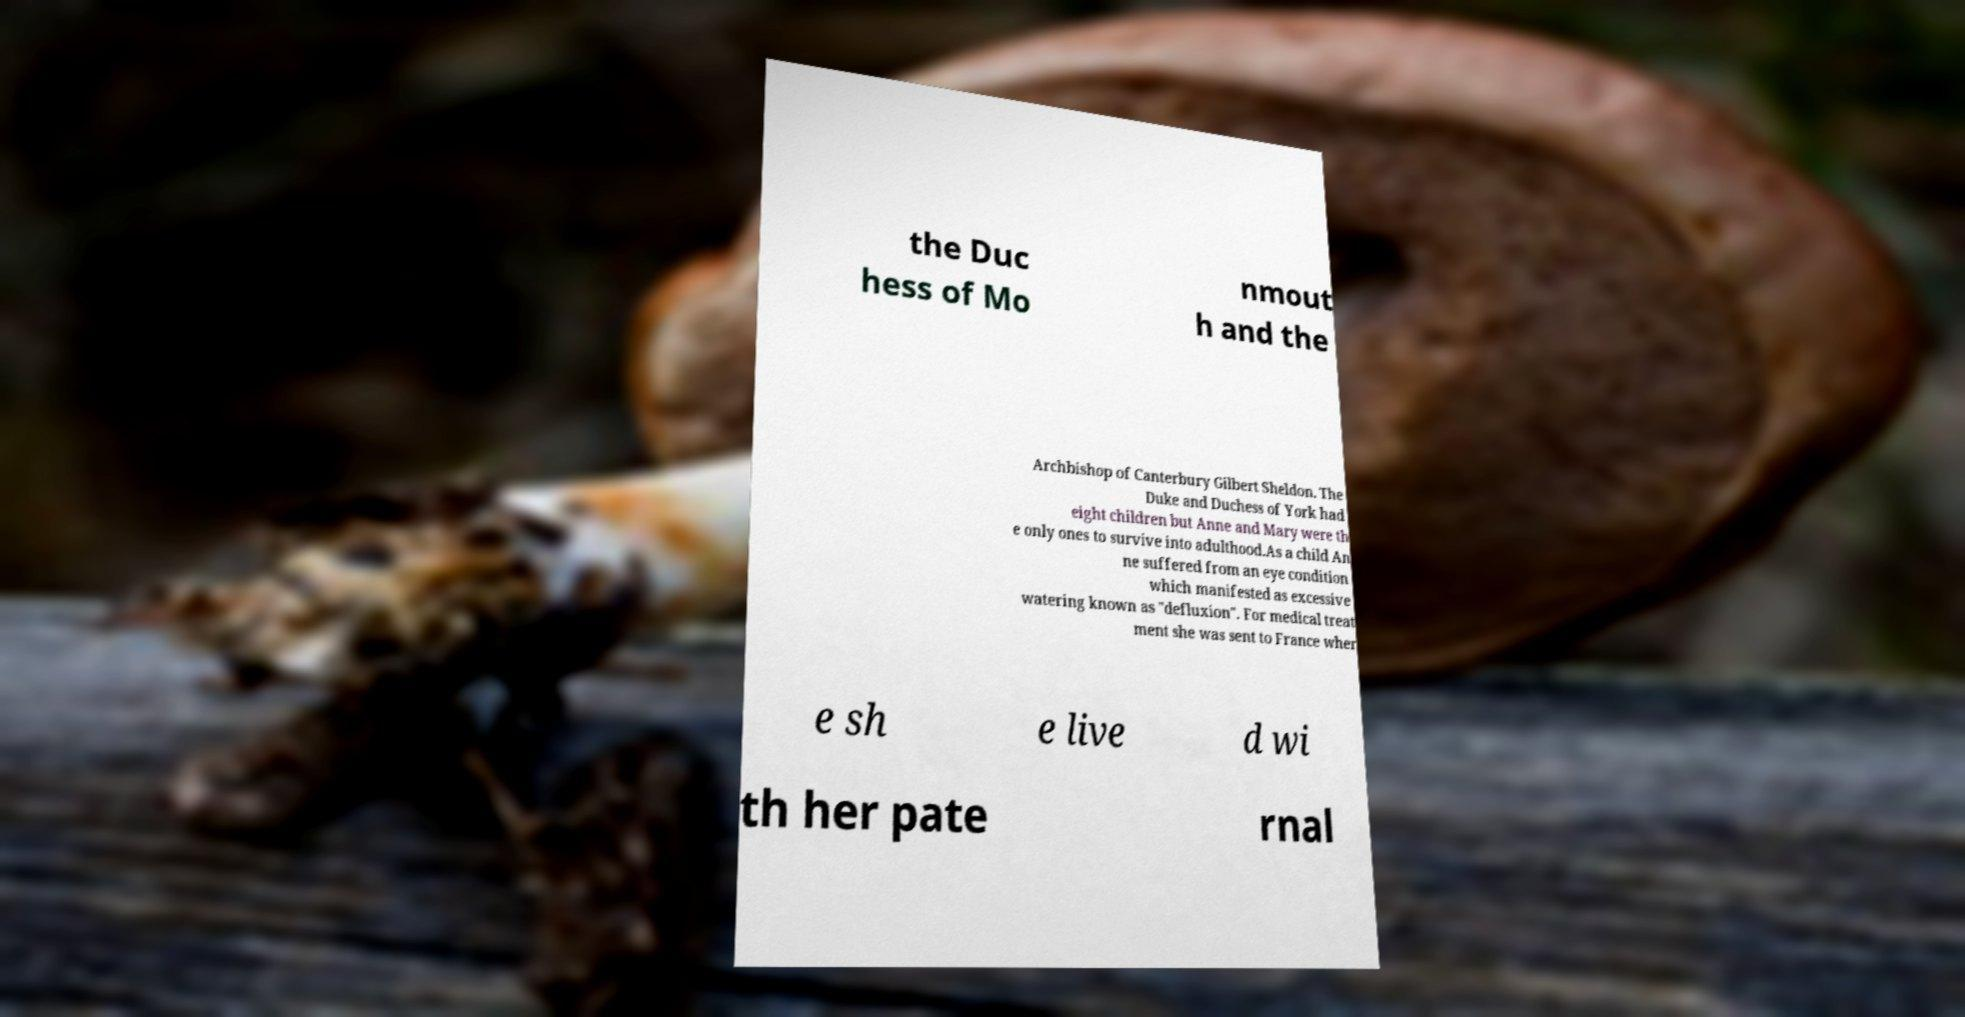Can you read and provide the text displayed in the image?This photo seems to have some interesting text. Can you extract and type it out for me? the Duc hess of Mo nmout h and the Archbishop of Canterbury Gilbert Sheldon. The Duke and Duchess of York had eight children but Anne and Mary were th e only ones to survive into adulthood.As a child An ne suffered from an eye condition which manifested as excessive watering known as "defluxion". For medical treat ment she was sent to France wher e sh e live d wi th her pate rnal 